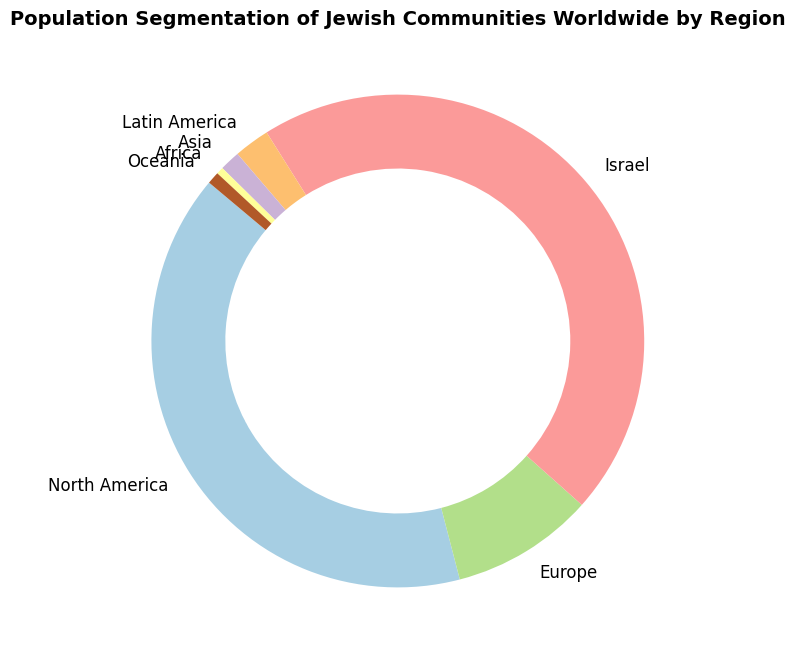What region has the largest Jewish population? The figure shows the distribution of the Jewish population across different regions. Israel has the largest section in the ring chart, indicating it has the largest Jewish population.
Answer: Israel Which regions have more than a million Jewish people? By looking at the sizes of the sections and their labels, Israel, North America, and Europe each have more than a million Jewish people.
Answer: Israel, North America, Europe How much larger is the Jewish population in Israel compared to Europe? Israel has 6,800,000, and Europe has 1,400,000. Subtracting Europe's population from Israel's gives: 6,800,000 - 1,400,000 = 5,400,000.
Answer: 5,400,000 Which region has the smallest Jewish population and what is it? The smallest section on the chart represents Africa, which has a population of 70,000.
Answer: Africa, 70,000 If we combine the populations of Latin America and Oceania, how does it compare to Europe's population? Latin America's population is 350,000, while Oceania's is 120,000. Adding them gives: 350,000 + 120,000 = 470,000, which is less than Europe's 1,400,000 population.
Answer: Less than Europe's Compare the Jewish populations of North America and Israel. Which one is larger and by how much? North America has 6,000,000 and Israel has 6,800,000. Israel's population is larger by: 6,800,000 - 6,000,000 = 800,000.
Answer: Israel by 800,000 What percentage of the total Jewish population resides in Asia based on the figure? Asia's population is 200,000. To find the percentage, first calculate the total population: 6,000,000 + 1,400,000 + 6,800,000 + 350,000 + 200,000 + 70,000 + 120,000 = 14,940,000. Then, (200,000/14,940,000) * 100 ≈ 1.34%.
Answer: 1.34% If the Jewish populations in Africa and Asia were combined, how would their total compare to Oceania's population? Africa's population is 70,000 and Asia's is 200,000. Their combined population is: 70,000 + 200,000 = 270,000, which is more than Oceania's 120,000 population.
Answer: More than Oceania's What's the average Jewish population among the regions presented? Sum the populations: 6,000,000 + 1,400,000 + 6,800,000 + 350,000 + 200,000 + 70,000 + 120,000 = 14,940,000. There are 7 regions, so the average is: 14,940,000 / 7 ≈ 2,134,286.
Answer: 2,134,286 